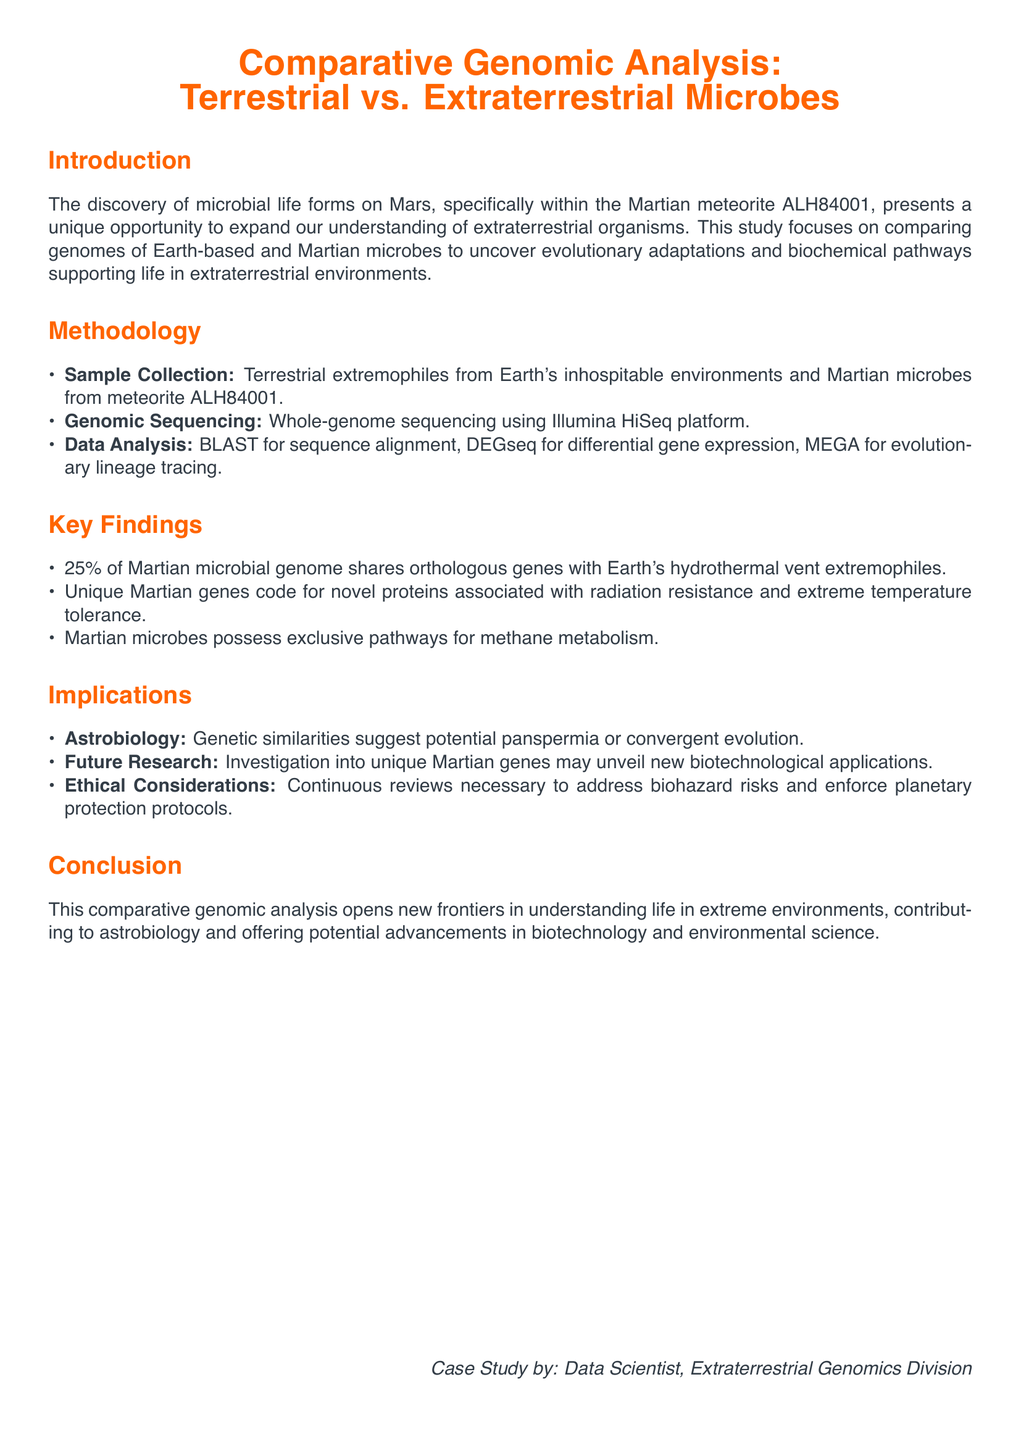What is the title of the case study? The title of the case study is stated at the beginning of the document.
Answer: Comparative Genomic Analysis: Terrestrial vs. Extraterrestrial Microbes What percentage of the Martian microbial genome shares orthologous genes with Earth's extremophiles? The document specifies that a certain percentage of the genome shares orthologous genes, which is provided in the key findings.
Answer: 25% What method was used for genomic sequencing? The document lists the method employed for sequencing in the methodology section.
Answer: Illumina HiSeq platform Which Martian meteorite is mentioned in the study? The document names the specific Martian meteorite from which microbial samples were collected.
Answer: ALH84001 What type of unique pathways do Martian microbes possess? The document highlights a specific type of metabolism unique to Martian microbes in the key findings.
Answer: Methane metabolism What does the study suggest regarding astrobiology? The implications section discusses the implications for astrobiology derived from the findings of the study.
Answer: Potential panspermia or convergent evolution What is a potential application of the unique Martian genes? The document mentions future research opportunities related to unique Martian genes in the implications section.
Answer: Biotechnology applications What is the primary focus of this case study? The introduction outlines the main objective of the research conducted.
Answer: Comparing genomes of Earth-based and Martian microbes 